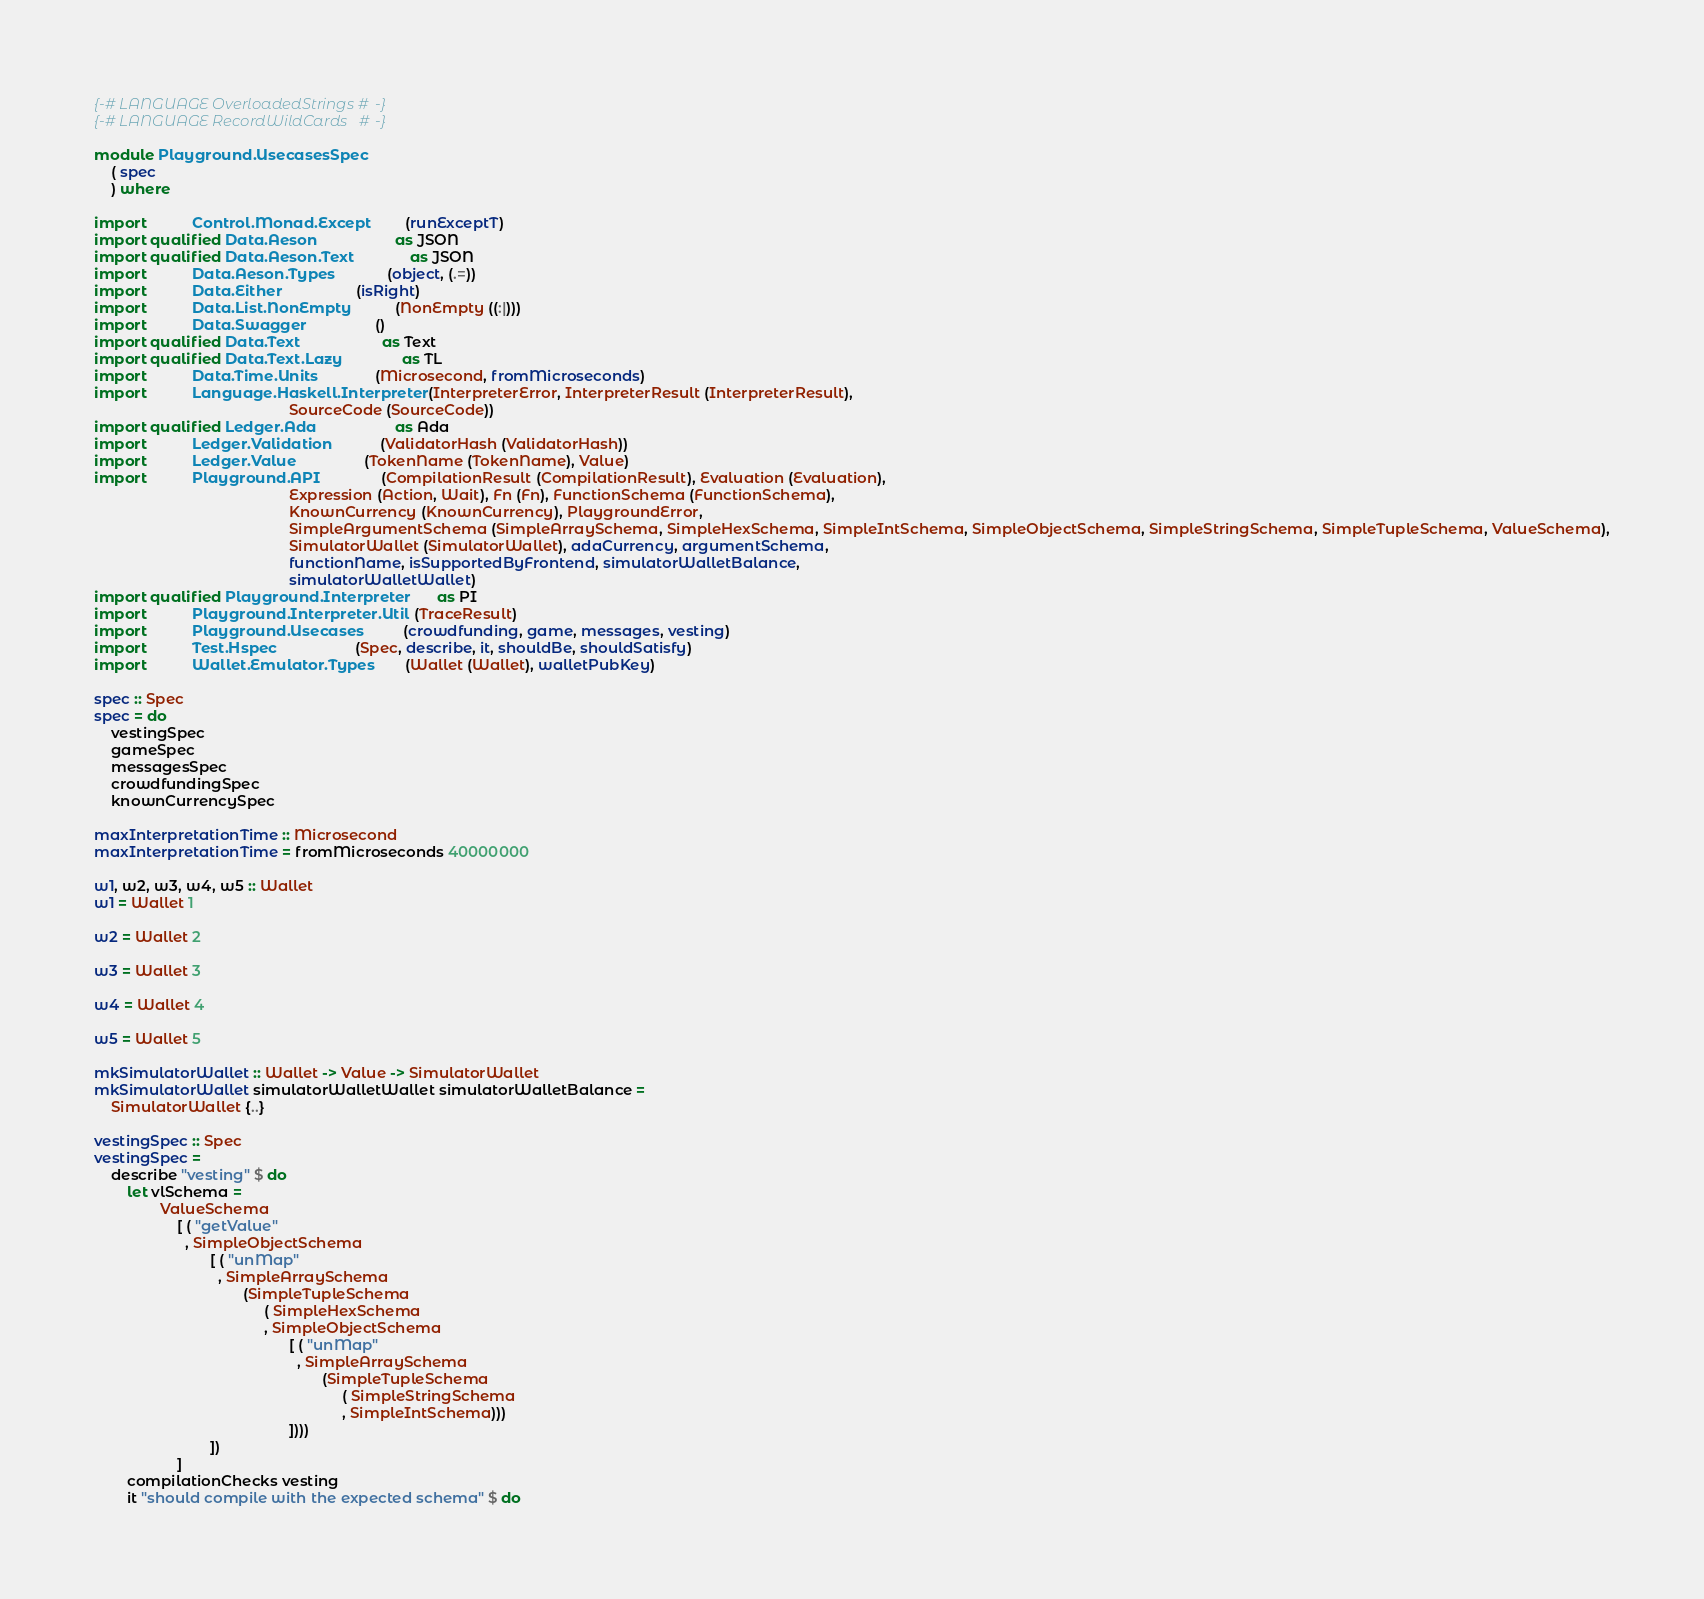<code> <loc_0><loc_0><loc_500><loc_500><_Haskell_>{-# LANGUAGE OverloadedStrings #-}
{-# LANGUAGE RecordWildCards   #-}

module Playground.UsecasesSpec
    ( spec
    ) where

import           Control.Monad.Except         (runExceptT)
import qualified Data.Aeson                   as JSON
import qualified Data.Aeson.Text              as JSON
import           Data.Aeson.Types             (object, (.=))
import           Data.Either                  (isRight)
import           Data.List.NonEmpty           (NonEmpty ((:|)))
import           Data.Swagger                 ()
import qualified Data.Text                    as Text
import qualified Data.Text.Lazy               as TL
import           Data.Time.Units              (Microsecond, fromMicroseconds)
import           Language.Haskell.Interpreter (InterpreterError, InterpreterResult (InterpreterResult),
                                               SourceCode (SourceCode))
import qualified Ledger.Ada                   as Ada
import           Ledger.Validation            (ValidatorHash (ValidatorHash))
import           Ledger.Value                 (TokenName (TokenName), Value)
import           Playground.API               (CompilationResult (CompilationResult), Evaluation (Evaluation),
                                               Expression (Action, Wait), Fn (Fn), FunctionSchema (FunctionSchema),
                                               KnownCurrency (KnownCurrency), PlaygroundError,
                                               SimpleArgumentSchema (SimpleArraySchema, SimpleHexSchema, SimpleIntSchema, SimpleObjectSchema, SimpleStringSchema, SimpleTupleSchema, ValueSchema),
                                               SimulatorWallet (SimulatorWallet), adaCurrency, argumentSchema,
                                               functionName, isSupportedByFrontend, simulatorWalletBalance,
                                               simulatorWalletWallet)
import qualified Playground.Interpreter       as PI
import           Playground.Interpreter.Util  (TraceResult)
import           Playground.Usecases          (crowdfunding, game, messages, vesting)
import           Test.Hspec                   (Spec, describe, it, shouldBe, shouldSatisfy)
import           Wallet.Emulator.Types        (Wallet (Wallet), walletPubKey)

spec :: Spec
spec = do
    vestingSpec
    gameSpec
    messagesSpec
    crowdfundingSpec
    knownCurrencySpec

maxInterpretationTime :: Microsecond
maxInterpretationTime = fromMicroseconds 40000000

w1, w2, w3, w4, w5 :: Wallet
w1 = Wallet 1

w2 = Wallet 2

w3 = Wallet 3

w4 = Wallet 4

w5 = Wallet 5

mkSimulatorWallet :: Wallet -> Value -> SimulatorWallet
mkSimulatorWallet simulatorWalletWallet simulatorWalletBalance =
    SimulatorWallet {..}

vestingSpec :: Spec
vestingSpec =
    describe "vesting" $ do
        let vlSchema =
                ValueSchema
                    [ ( "getValue"
                      , SimpleObjectSchema
                            [ ( "unMap"
                              , SimpleArraySchema
                                    (SimpleTupleSchema
                                         ( SimpleHexSchema
                                         , SimpleObjectSchema
                                               [ ( "unMap"
                                                 , SimpleArraySchema
                                                       (SimpleTupleSchema
                                                            ( SimpleStringSchema
                                                            , SimpleIntSchema)))
                                               ])))
                            ])
                    ]
        compilationChecks vesting
        it "should compile with the expected schema" $ do</code> 